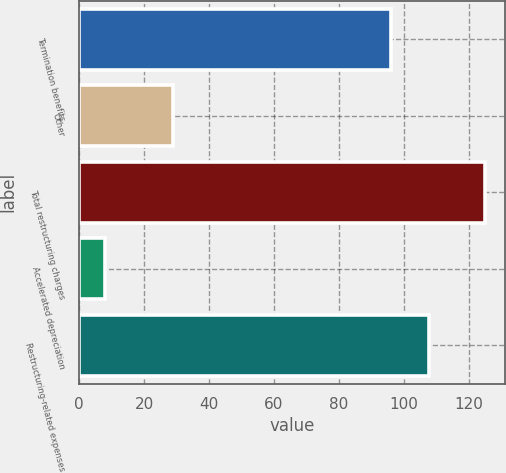Convert chart to OTSL. <chart><loc_0><loc_0><loc_500><loc_500><bar_chart><fcel>Termination benefits<fcel>Other<fcel>Total restructuring charges<fcel>Accelerated depreciation<fcel>Restructuring-related expenses<nl><fcel>96<fcel>29<fcel>125<fcel>8<fcel>107.7<nl></chart> 